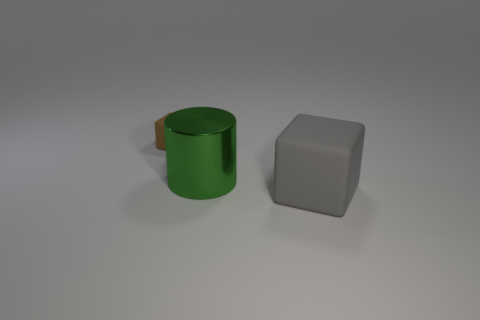What size is the object that is to the left of the gray matte block and in front of the brown object?
Ensure brevity in your answer.  Large. What number of metal cylinders are right of the large green shiny cylinder that is behind the block on the right side of the brown thing?
Make the answer very short. 0. What is the color of the thing that is the same size as the green metal cylinder?
Offer a very short reply. Gray. What shape is the matte object that is right of the matte cube behind the block that is to the right of the brown cube?
Your response must be concise. Cube. What number of small rubber blocks are in front of the matte cube that is in front of the small brown matte object?
Provide a succinct answer. 0. Is the shape of the matte object that is left of the big gray cube the same as the large thing that is behind the big matte object?
Your response must be concise. No. There is a metallic cylinder; how many big green metal cylinders are on the left side of it?
Provide a short and direct response. 0. Are the cube that is in front of the small brown matte thing and the tiny cube made of the same material?
Your answer should be compact. Yes. What is the color of the tiny object that is the same shape as the large gray matte object?
Offer a terse response. Brown. What is the shape of the tiny brown object?
Offer a terse response. Cube. 